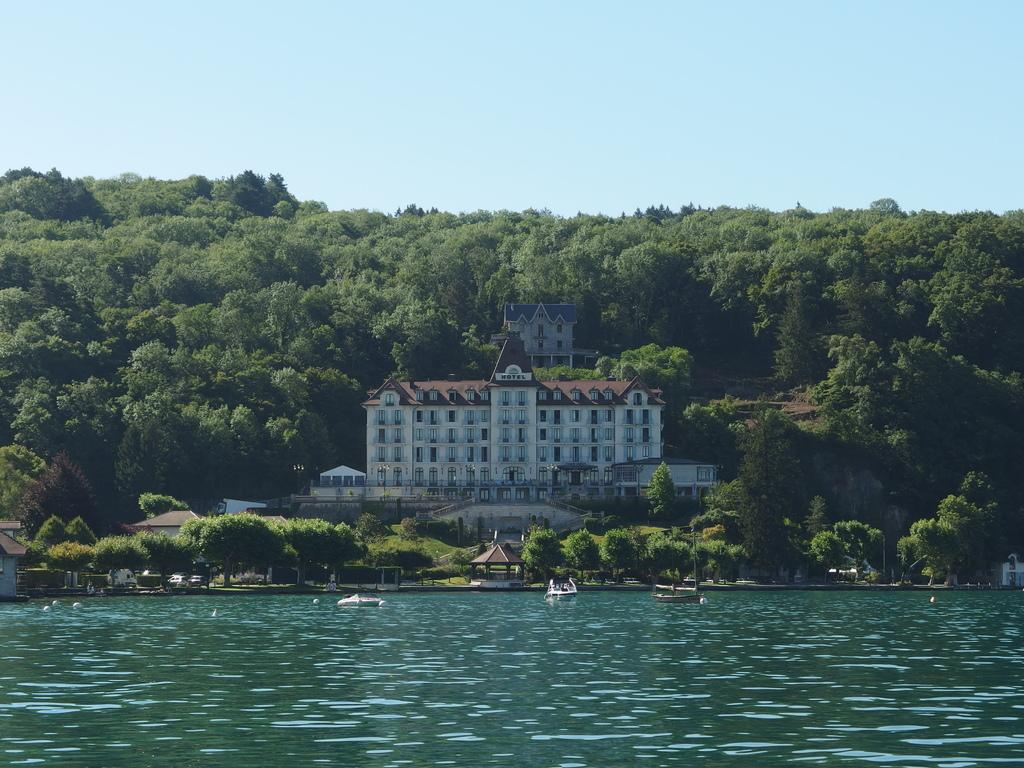What is located at the front of the image? There is water in the front of the image. What can be seen in the background of the image? There is a castle and trees in the background of the image. What is happening in the center of the image? There are boats sailing on the water in the center of the image. What type of structures are present in the image? There are huts in the image. How does the earthquake affect the castle in the image? There is no earthquake present in the image, so its effect on the castle cannot be determined. What type of pest can be seen in the image? There are no pests visible in the image; it features water, a castle, trees, boats, and huts. 